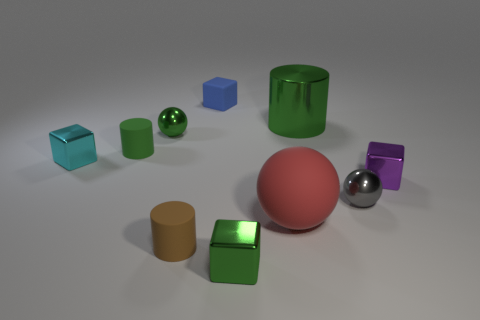Subtract all green cylinders. How many were subtracted if there are1green cylinders left? 1 Subtract all large shiny cylinders. How many cylinders are left? 2 Subtract 2 balls. How many balls are left? 1 Subtract all brown cylinders. How many cylinders are left? 2 Subtract all balls. How many objects are left? 7 Subtract all purple cubes. How many red spheres are left? 1 Subtract 0 gray cylinders. How many objects are left? 10 Subtract all red balls. Subtract all cyan cylinders. How many balls are left? 2 Subtract all tiny green things. Subtract all large metallic objects. How many objects are left? 6 Add 1 matte objects. How many matte objects are left? 5 